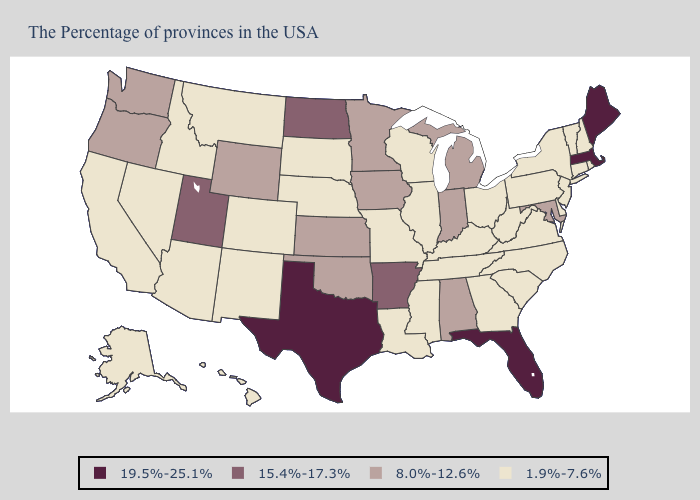Name the states that have a value in the range 15.4%-17.3%?
Short answer required. Arkansas, North Dakota, Utah. What is the value of North Carolina?
Concise answer only. 1.9%-7.6%. Name the states that have a value in the range 8.0%-12.6%?
Quick response, please. Maryland, Michigan, Indiana, Alabama, Minnesota, Iowa, Kansas, Oklahoma, Wyoming, Washington, Oregon. Does Vermont have the lowest value in the Northeast?
Short answer required. Yes. What is the value of Rhode Island?
Answer briefly. 1.9%-7.6%. Name the states that have a value in the range 19.5%-25.1%?
Concise answer only. Maine, Massachusetts, Florida, Texas. Name the states that have a value in the range 8.0%-12.6%?
Concise answer only. Maryland, Michigan, Indiana, Alabama, Minnesota, Iowa, Kansas, Oklahoma, Wyoming, Washington, Oregon. What is the value of Oregon?
Short answer required. 8.0%-12.6%. Which states hav the highest value in the South?
Keep it brief. Florida, Texas. What is the lowest value in the USA?
Answer briefly. 1.9%-7.6%. Among the states that border Louisiana , does Mississippi have the lowest value?
Short answer required. Yes. Does Alabama have a lower value than Utah?
Write a very short answer. Yes. What is the highest value in the Northeast ?
Write a very short answer. 19.5%-25.1%. Name the states that have a value in the range 15.4%-17.3%?
Short answer required. Arkansas, North Dakota, Utah. What is the value of Oregon?
Short answer required. 8.0%-12.6%. 